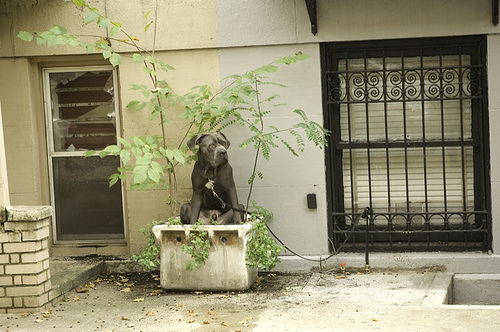<image>
Can you confirm if the leash is in front of the window? Yes. The leash is positioned in front of the window, appearing closer to the camera viewpoint. Where is the flower pot in relation to the dog? Is it in front of the dog? No. The flower pot is not in front of the dog. The spatial positioning shows a different relationship between these objects. 